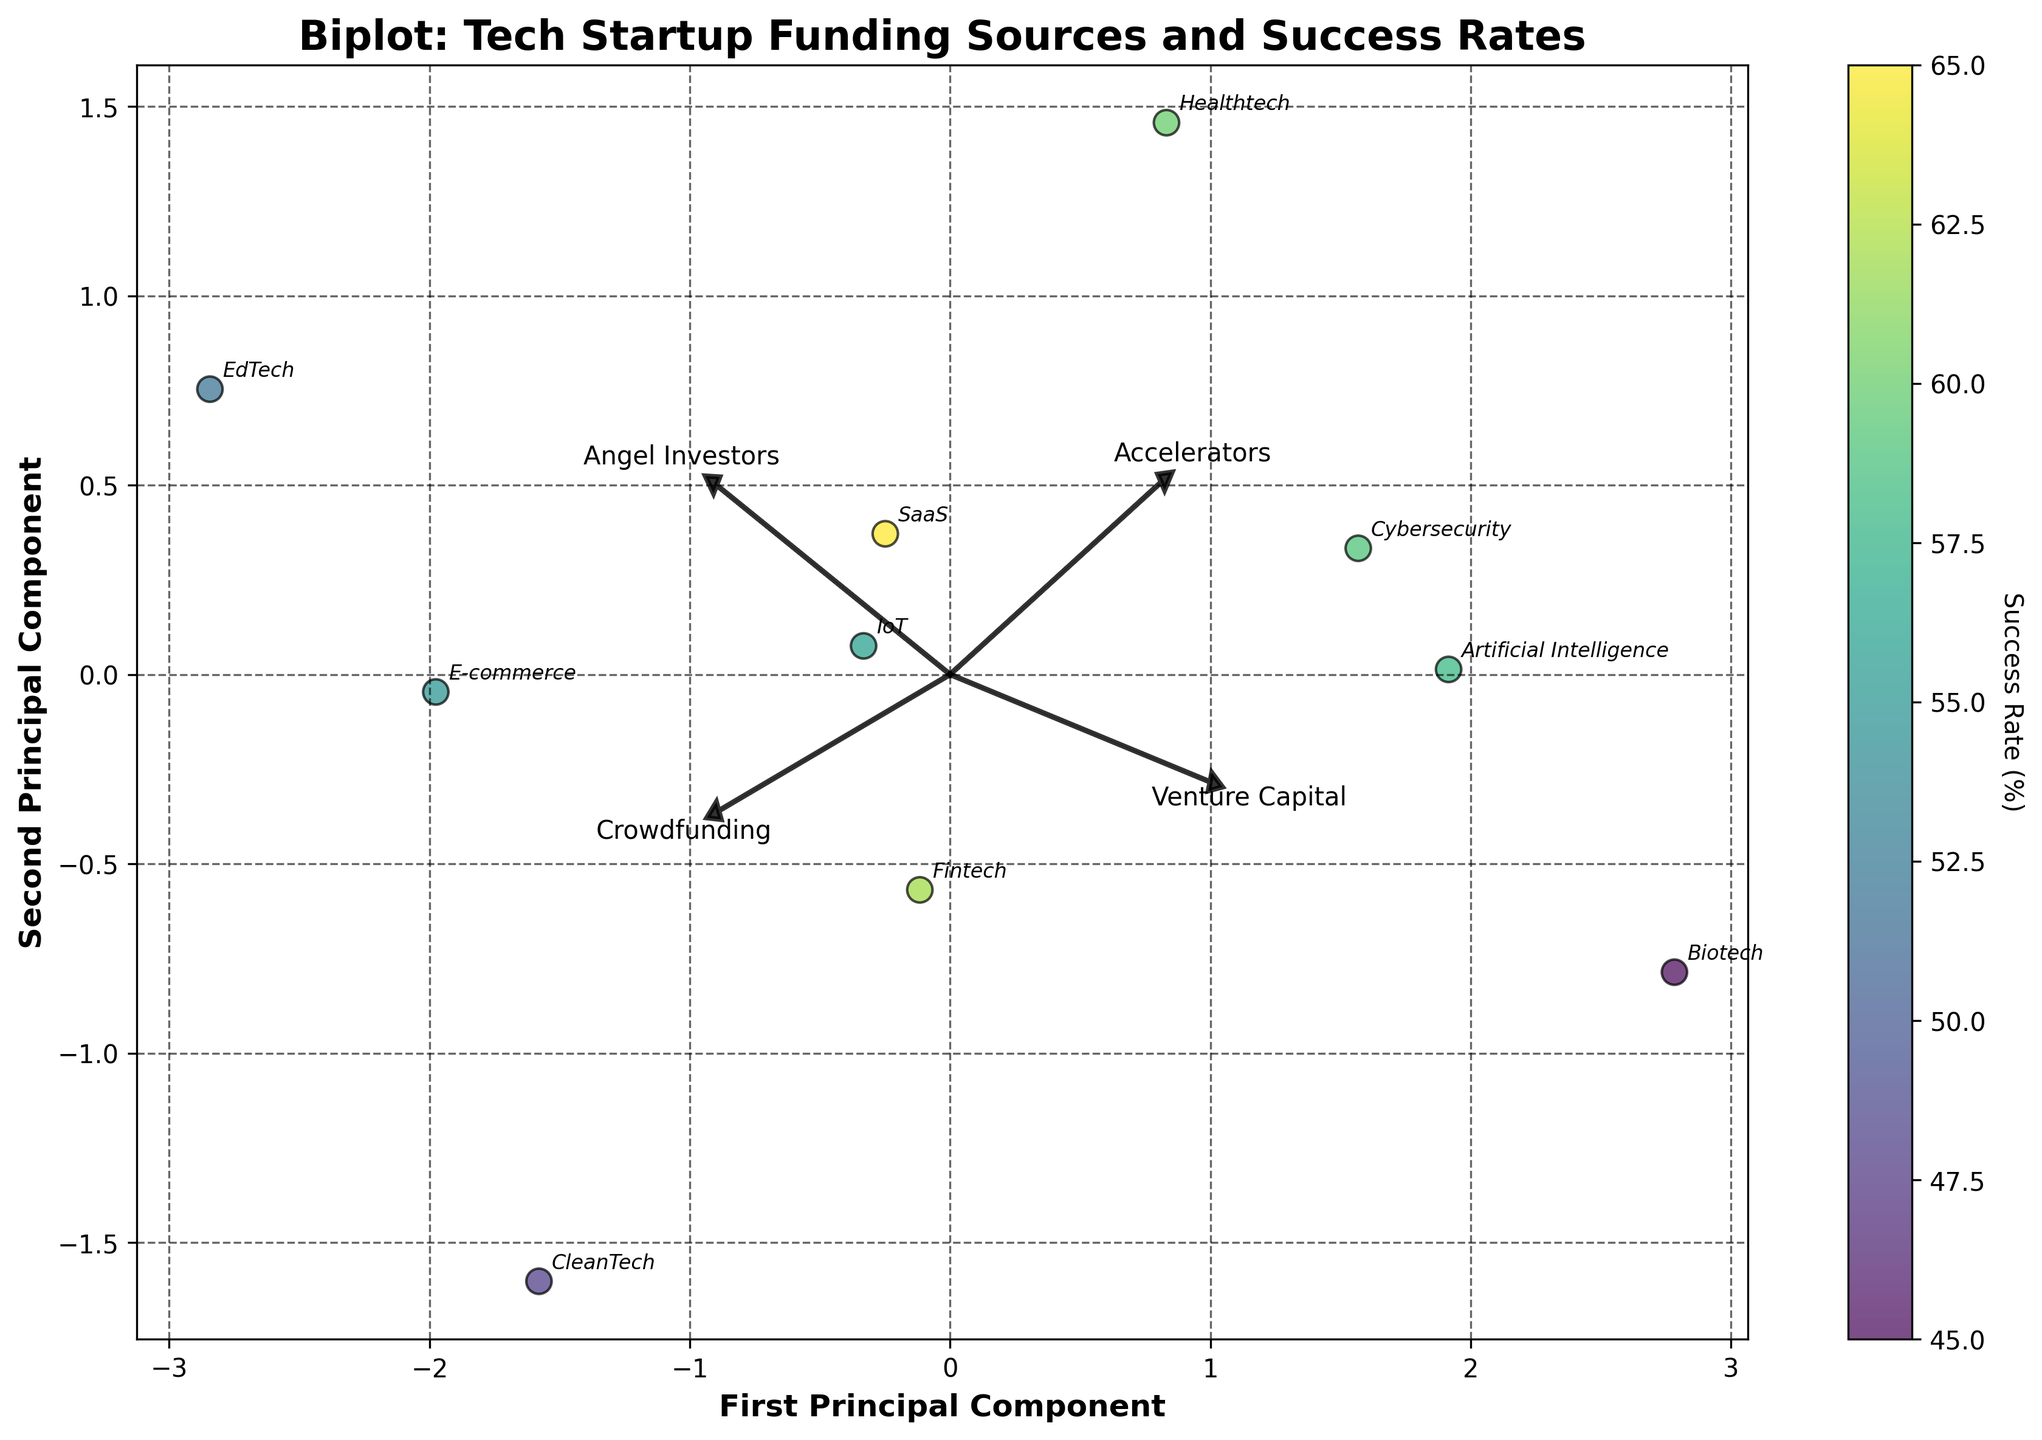What is the title of the plot? The title of the plot is indicated at the top of the figure. By looking at the top of the figure, the title reads "Biplot: Tech Startup Funding Sources and Success Rates."
Answer: Biplot: Tech Startup Funding Sources and Success Rates Which industry has the highest success rate according to the color scale? The color scale on the right of the plot shows varying coloration, where the highest value indicates the highest success rate. By examining the data points and their colors, the brightest color corresponds to the SaaS industry.
Answer: SaaS What does the first principal component represent on the x-axis? The x-axis is labeled "First Principal Component," which represents the principal component derived from the funding sources data, explaining most of the variance. The first principal component indicates the dominant pattern in the data variation.
Answer: First Principal Component Which two industries are positioned closest to each other on the biplot? By looking at the relative positions of the data points on the biplot, the two industries that are closest to each other are Fintech and Cybersecurity.
Answer: Fintech and Cybersecurity How do Venture Capital and Angel Investors arrows compare in direction and length? The arrows represent eigenvectors and show the direction and magnitude of the features. Venture Capital has a longer arrow pointing in a horizontal right direction, while Angel Investors' arrow is shorter and points diagonally upwards. This implies Venture Capital has a higher variance contribution in that direction.
Answer: Venture Capital is longer and horizontal; Angel Investors is shorter and diagonal Which funding source is most closely associated with the second principal component on the y-axis? The second principal component on the y-axis can be associated with a feature by looking at the arrows. The arrow pointing most closely in the vertical direction corresponds to Accelerators, indicating a stronger association with the second principal component.
Answer: Accelerators Is there an industry with a higher success rate than EdTech but a lower use of Angel Investors? By examining the data points and the color scale, IoT has a higher success rate than EdTech and its point is positioned lower along the Angel Investors arrow, indicating lower use of Angel Investors.
Answer: IoT What is the relationship between Crowdfunding and Success Rate? To infer the relationship, one would look at the direction and magnitude of the Crowdfunding arrow in relation to the Success Rate color gradient. The Crowdfunding arrow is not strongly aligned with areas of higher success rate coloration, suggesting a weaker positive relation.
Answer: Weakly positive relation Which funding source shows the least variance in the data set according to its arrow length? Arrow lengths in a biplot signify the variance in the data explained by that feature. The shortest arrow among the listed funding sources is Crowdfunding, indicating it explains the least variance.
Answer: Crowdfunding 